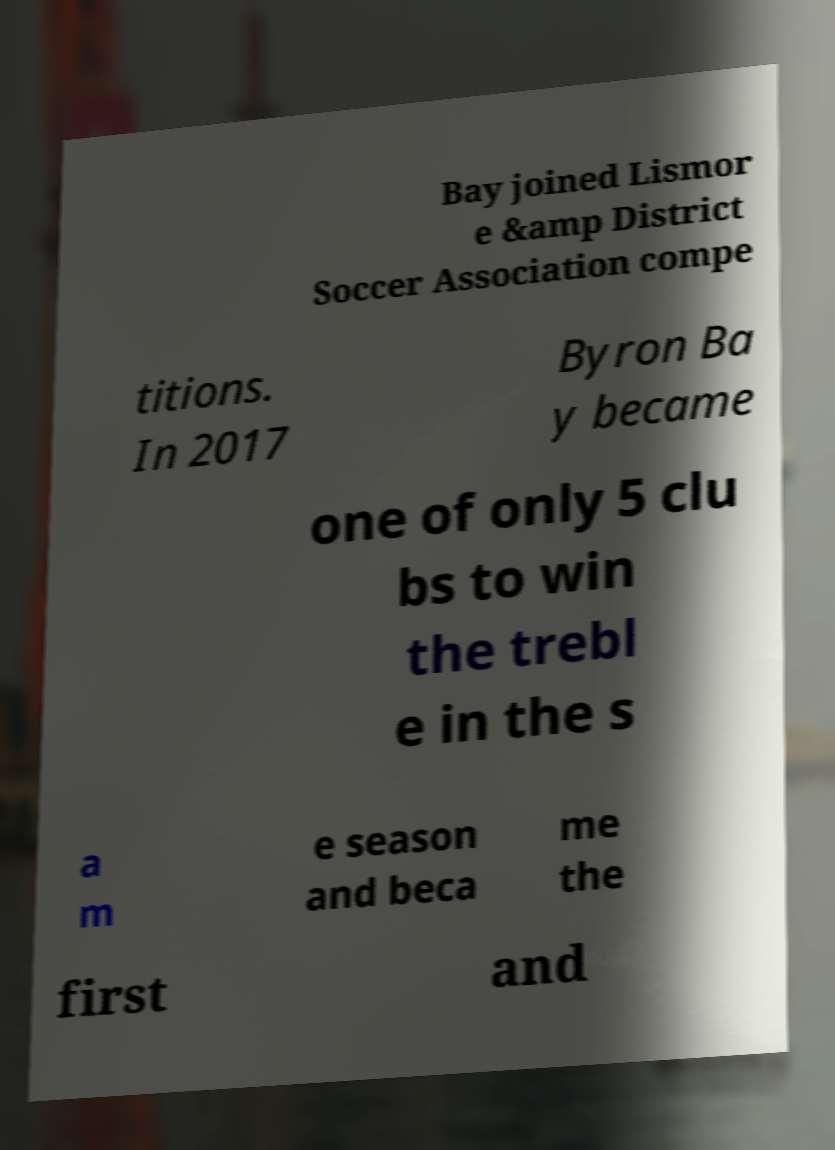Can you accurately transcribe the text from the provided image for me? Bay joined Lismor e &amp District Soccer Association compe titions. In 2017 Byron Ba y became one of only 5 clu bs to win the trebl e in the s a m e season and beca me the first and 